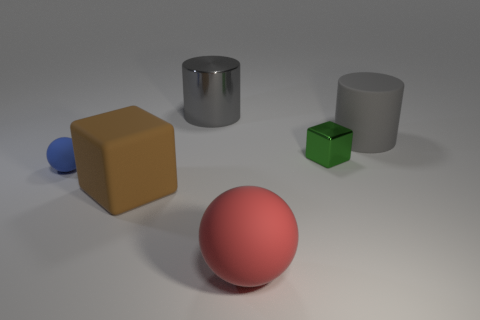Is there any other thing that has the same color as the rubber cylinder?
Your response must be concise. Yes. The thing that is the same color as the rubber cylinder is what shape?
Ensure brevity in your answer.  Cylinder. What number of brown rubber things have the same shape as the gray shiny thing?
Offer a terse response. 0. The block that is the same size as the red matte object is what color?
Offer a terse response. Brown. What is the color of the object behind the big object that is to the right of the small object behind the blue thing?
Your answer should be very brief. Gray. There is a brown matte cube; is its size the same as the metallic thing right of the red ball?
Keep it short and to the point. No. How many things are either blue metal cylinders or cylinders?
Your answer should be very brief. 2. Are there any tiny blue objects that have the same material as the large red object?
Provide a short and direct response. Yes. The other cylinder that is the same color as the large metal cylinder is what size?
Your answer should be compact. Large. What is the color of the large rubber thing that is on the left side of the gray cylinder behind the gray matte thing?
Give a very brief answer. Brown. 